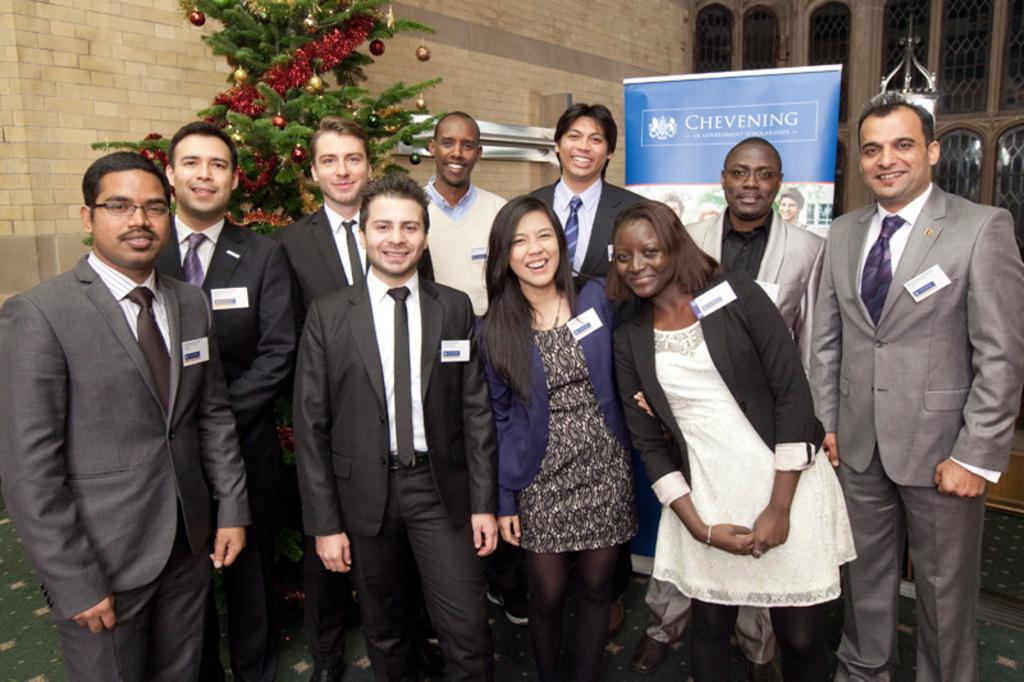Can you describe this image briefly? In this picture I can see few people standing and I can see they are wearing name badges and I can see a tree in the back and I can see few decorative balls and papers to the tree and I can see an advertisement board with some text and pictures and I can see building in the back. 